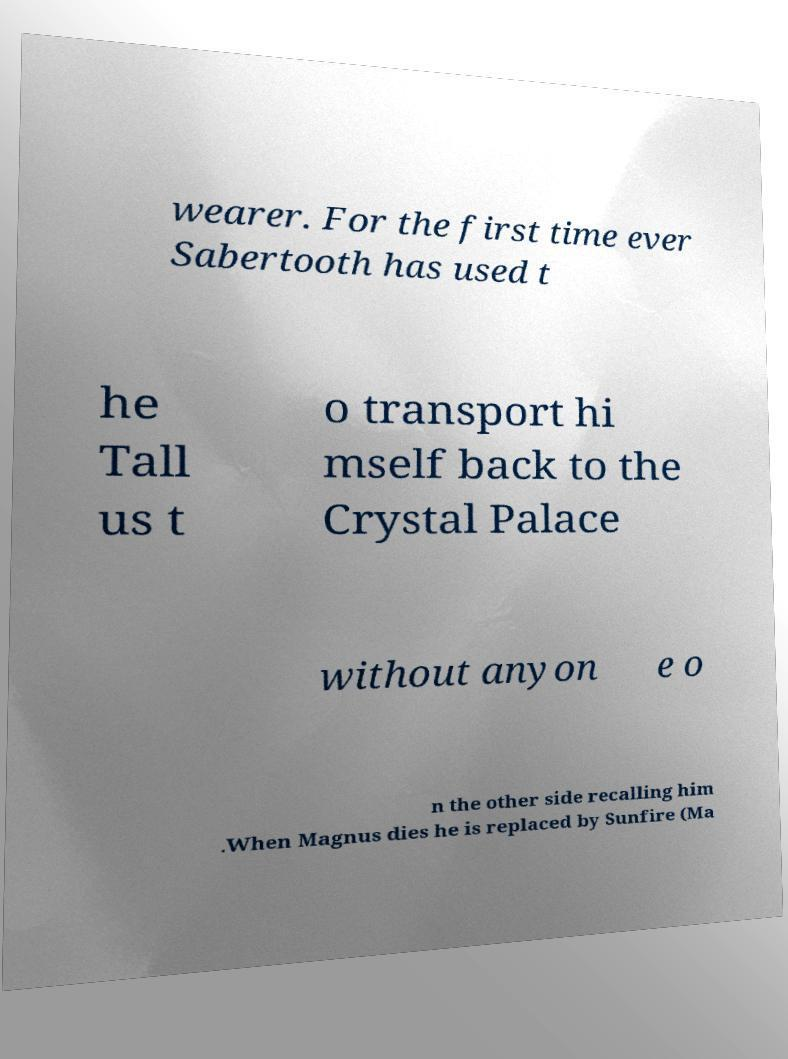For documentation purposes, I need the text within this image transcribed. Could you provide that? wearer. For the first time ever Sabertooth has used t he Tall us t o transport hi mself back to the Crystal Palace without anyon e o n the other side recalling him .When Magnus dies he is replaced by Sunfire (Ma 